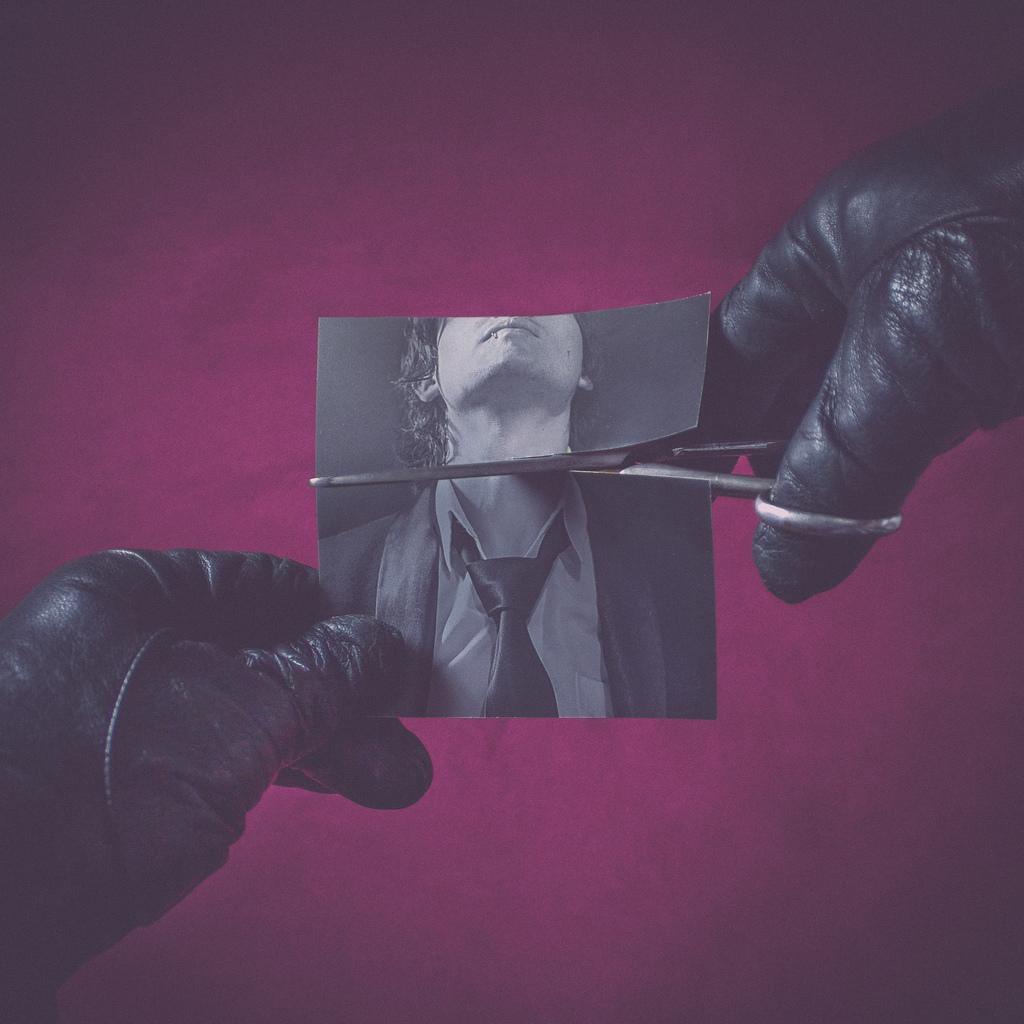Could you give a brief overview of what you see in this image? In the image in the center, we can see human hands holding a scissor and photo. In the photo, we can see one person. 